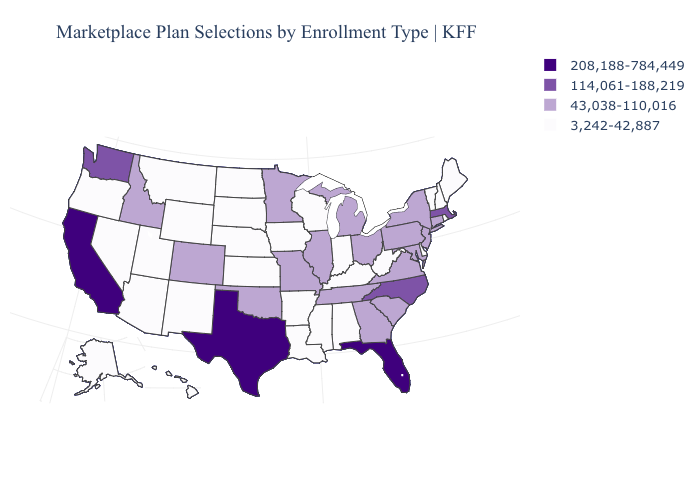Name the states that have a value in the range 43,038-110,016?
Quick response, please. Colorado, Connecticut, Georgia, Idaho, Illinois, Maryland, Michigan, Minnesota, Missouri, New Jersey, New York, Ohio, Oklahoma, Pennsylvania, South Carolina, Tennessee, Virginia. What is the value of Arkansas?
Short answer required. 3,242-42,887. Does Hawaii have the highest value in the USA?
Keep it brief. No. Among the states that border Maine , which have the highest value?
Be succinct. New Hampshire. Name the states that have a value in the range 43,038-110,016?
Keep it brief. Colorado, Connecticut, Georgia, Idaho, Illinois, Maryland, Michigan, Minnesota, Missouri, New Jersey, New York, Ohio, Oklahoma, Pennsylvania, South Carolina, Tennessee, Virginia. Name the states that have a value in the range 114,061-188,219?
Give a very brief answer. Massachusetts, North Carolina, Washington. Name the states that have a value in the range 114,061-188,219?
Give a very brief answer. Massachusetts, North Carolina, Washington. Which states hav the highest value in the West?
Be succinct. California. Among the states that border Georgia , which have the highest value?
Give a very brief answer. Florida. What is the value of Maryland?
Short answer required. 43,038-110,016. Among the states that border Nevada , which have the highest value?
Write a very short answer. California. Name the states that have a value in the range 208,188-784,449?
Quick response, please. California, Florida, Texas. What is the lowest value in states that border Utah?
Be succinct. 3,242-42,887. What is the value of Minnesota?
Short answer required. 43,038-110,016. Does Louisiana have a lower value than North Dakota?
Keep it brief. No. 